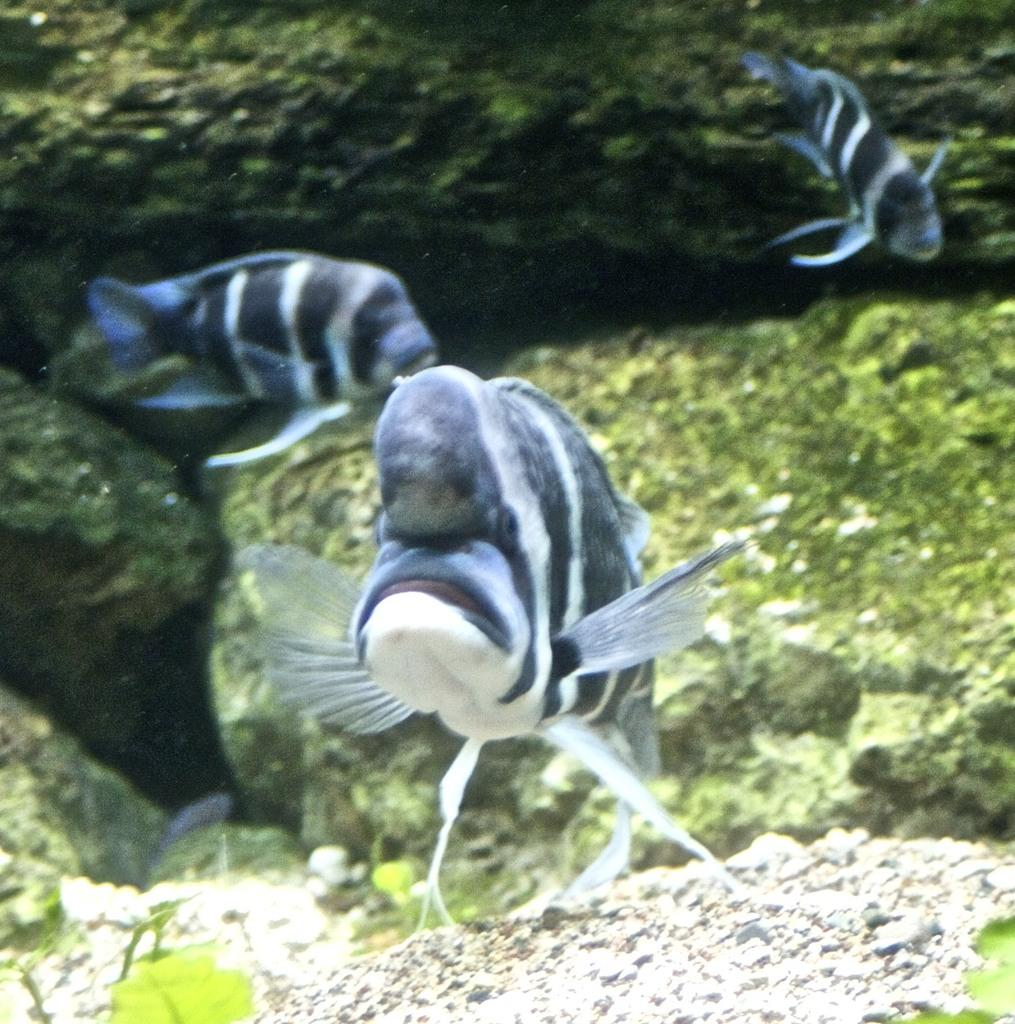What type of animals can be seen in the image? There are fishes in the image. What type of vegetation is present in the image? There are green leaves in the image. What is the primary element in which the fishes are situated? There is water visible in the image. Can you tell me how the frog blows bubbles in the image? There is no frog present in the image, and therefore no such activity can be observed. How many times does the fish sneeze in the image? Fish do not have the ability to sneeze, and there are no sneezing fish in the image. 